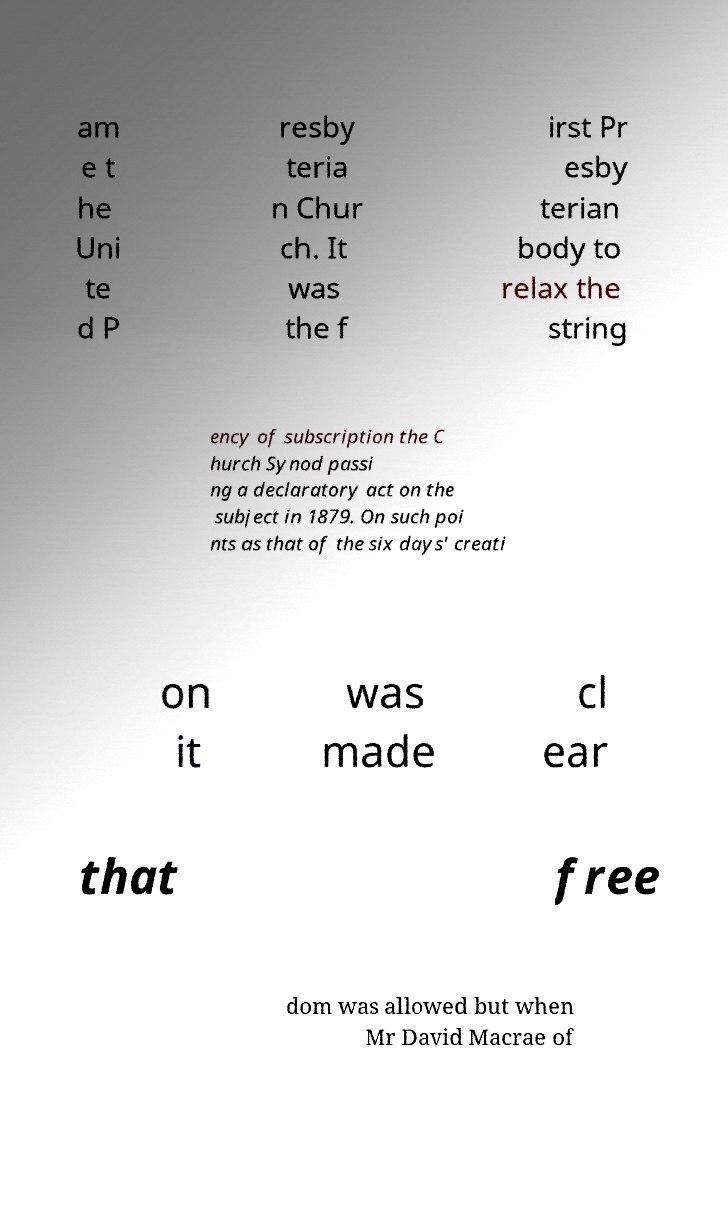Can you accurately transcribe the text from the provided image for me? am e t he Uni te d P resby teria n Chur ch. It was the f irst Pr esby terian body to relax the string ency of subscription the C hurch Synod passi ng a declaratory act on the subject in 1879. On such poi nts as that of the six days' creati on it was made cl ear that free dom was allowed but when Mr David Macrae of 